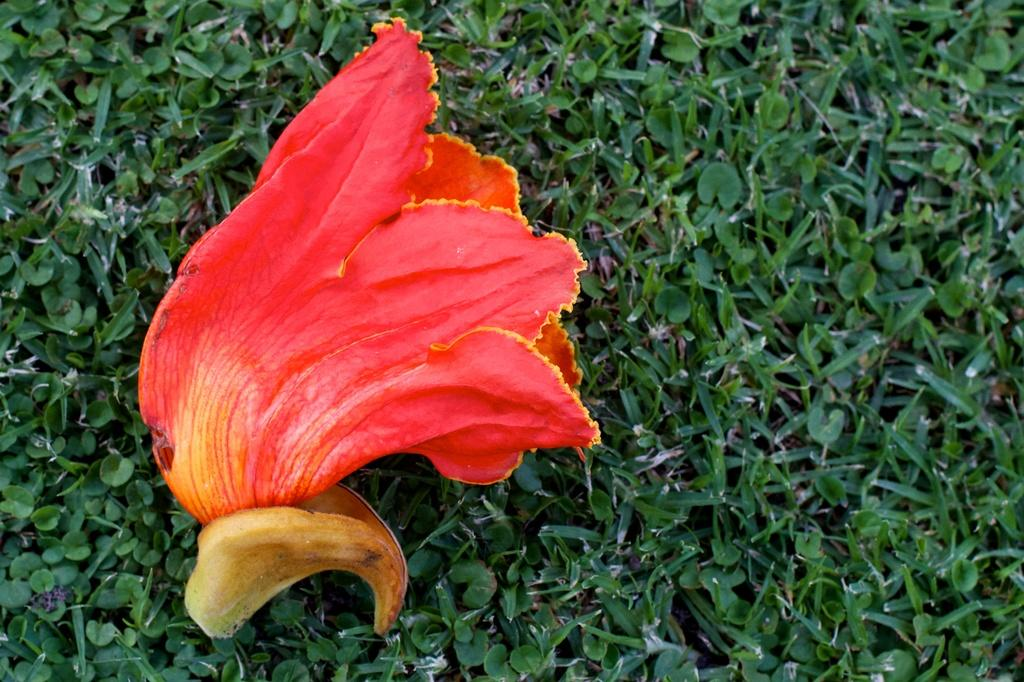What type of vegetation can be seen in the image? There is grass in the image. What colors are the flowers in the image? The flowers in the image are red and yellow. Where can you buy the red and yellow socks in the image? There are no socks present in the image, only red and yellow flowers. 